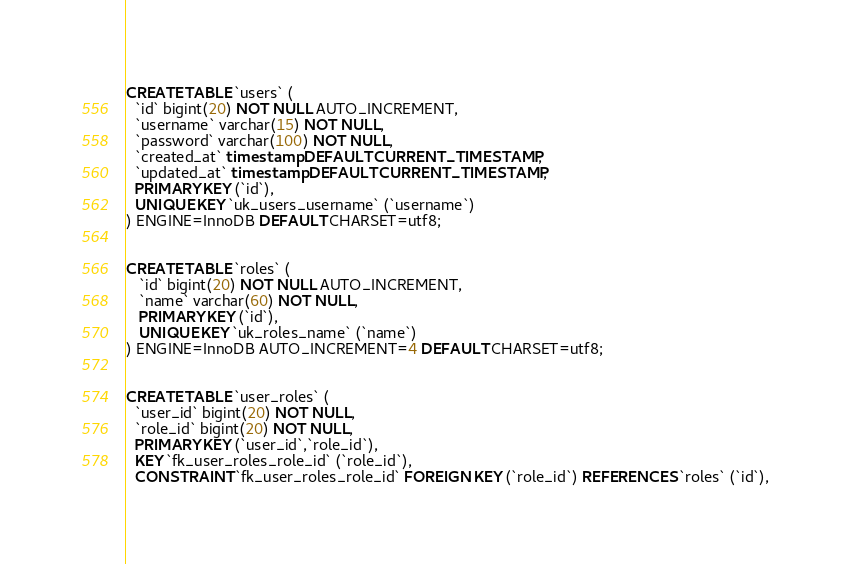<code> <loc_0><loc_0><loc_500><loc_500><_SQL_>CREATE TABLE `users` (
  `id` bigint(20) NOT NULL AUTO_INCREMENT,
  `username` varchar(15) NOT NULL,
  `password` varchar(100) NOT NULL,
  `created_at` timestamp DEFAULT CURRENT_TIMESTAMP,
  `updated_at` timestamp DEFAULT CURRENT_TIMESTAMP,
  PRIMARY KEY (`id`),
  UNIQUE KEY `uk_users_username` (`username`)
) ENGINE=InnoDB DEFAULT CHARSET=utf8;


CREATE TABLE `roles` (
   `id` bigint(20) NOT NULL AUTO_INCREMENT,
   `name` varchar(60) NOT NULL,
   PRIMARY KEY (`id`),
   UNIQUE KEY `uk_roles_name` (`name`)
) ENGINE=InnoDB AUTO_INCREMENT=4 DEFAULT CHARSET=utf8;


CREATE TABLE `user_roles` (
  `user_id` bigint(20) NOT NULL,
  `role_id` bigint(20) NOT NULL,
  PRIMARY KEY (`user_id`,`role_id`),
  KEY `fk_user_roles_role_id` (`role_id`),
  CONSTRAINT `fk_user_roles_role_id` FOREIGN KEY (`role_id`) REFERENCES `roles` (`id`),</code> 